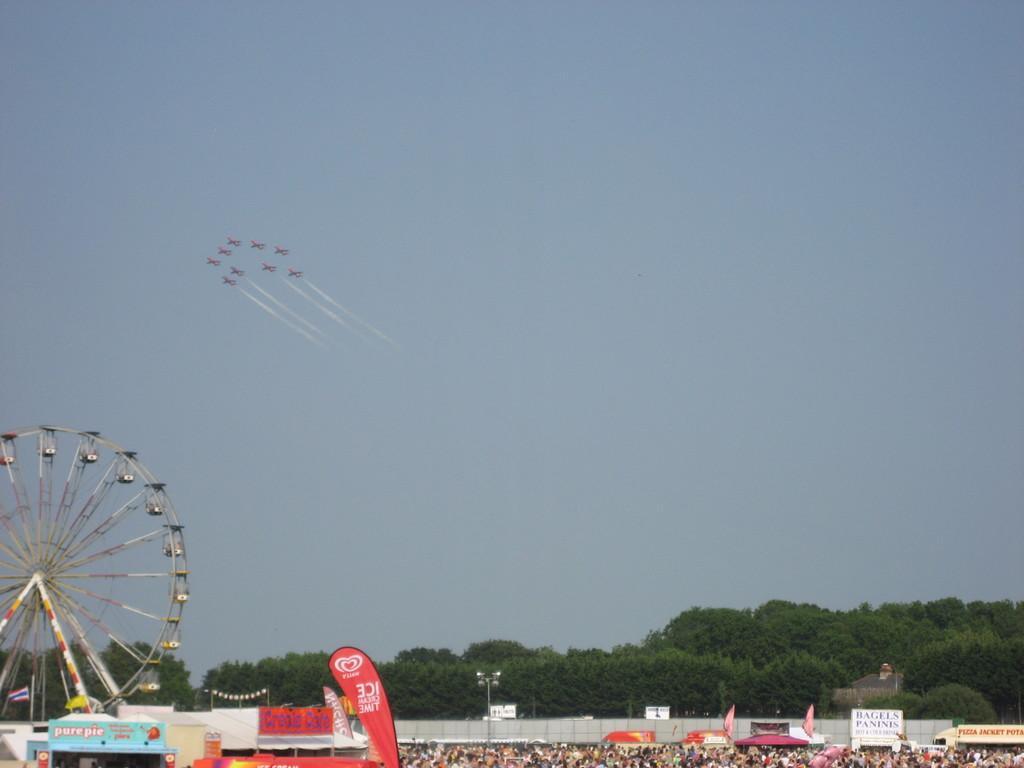Can you describe this image briefly? In the image there is a giant wheel on the left side and it seems to be a carnival beside it and over the background there are trees and above there are aeroplanes going in the sky. 